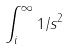Convert formula to latex. <formula><loc_0><loc_0><loc_500><loc_500>\int _ { i } ^ { \infty } 1 / s ^ { 2 }</formula> 